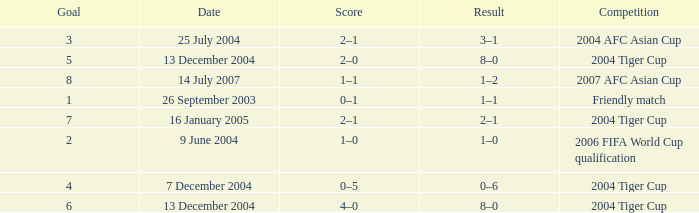Which date has 3 as the goal? 25 July 2004. 